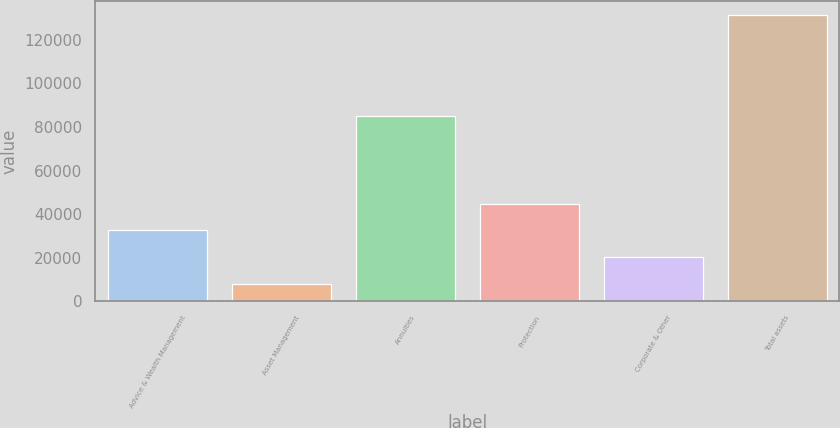<chart> <loc_0><loc_0><loc_500><loc_500><bar_chart><fcel>Advice & Wealth Management<fcel>Asset Management<fcel>Annuities<fcel>Protection<fcel>Corporate & Other<fcel>Total assets<nl><fcel>32521.6<fcel>7854<fcel>84836<fcel>44855.4<fcel>20187.8<fcel>131192<nl></chart> 